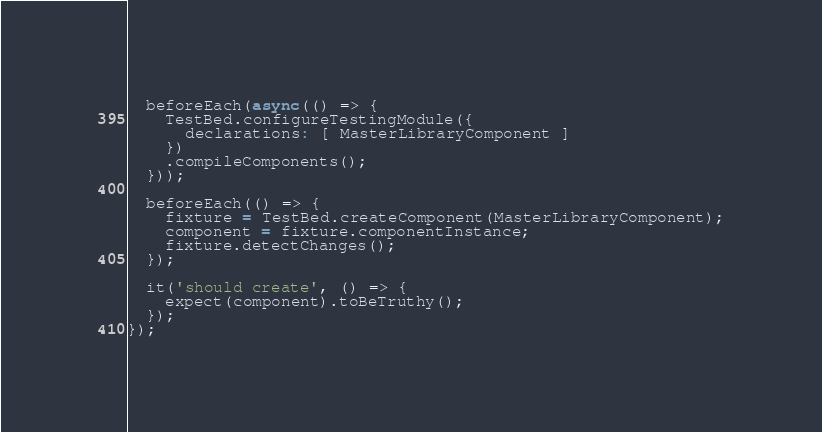Convert code to text. <code><loc_0><loc_0><loc_500><loc_500><_TypeScript_>
  beforeEach(async(() => {
    TestBed.configureTestingModule({
      declarations: [ MasterLibraryComponent ]
    })
    .compileComponents();
  }));

  beforeEach(() => {
    fixture = TestBed.createComponent(MasterLibraryComponent);
    component = fixture.componentInstance;
    fixture.detectChanges();
  });

  it('should create', () => {
    expect(component).toBeTruthy();
  });
});
</code> 